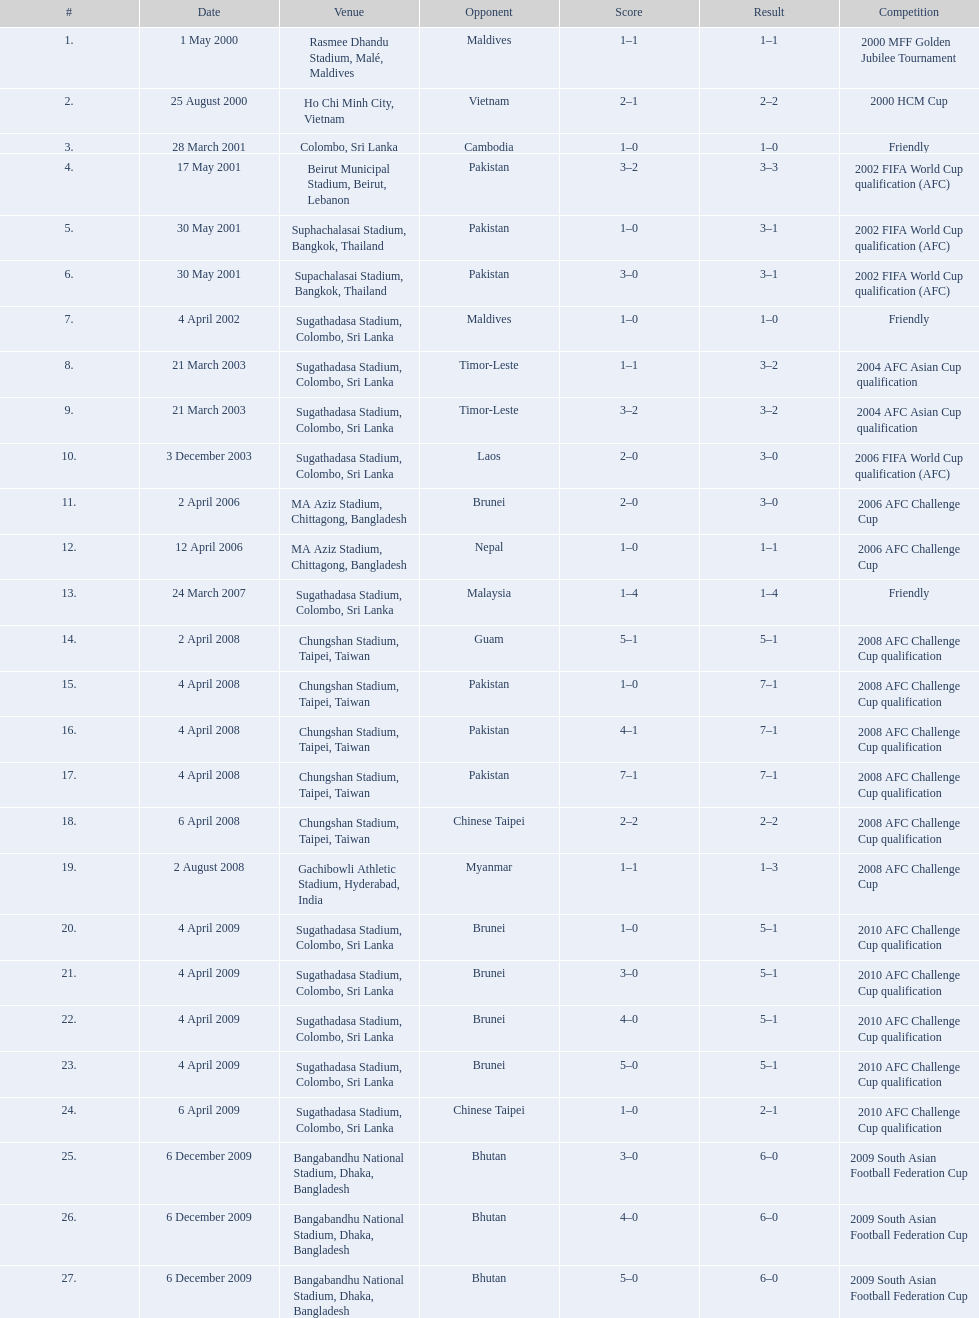What number of venues are present in the table? 27. Which one is ranked highest? Rasmee Dhandu Stadium, Malé, Maldives. 